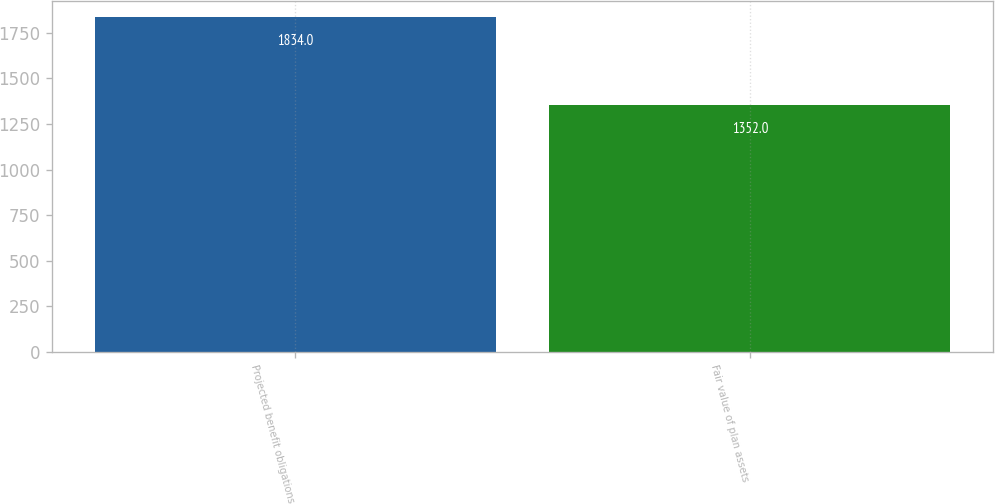<chart> <loc_0><loc_0><loc_500><loc_500><bar_chart><fcel>Projected benefit obligations<fcel>Fair value of plan assets<nl><fcel>1834<fcel>1352<nl></chart> 